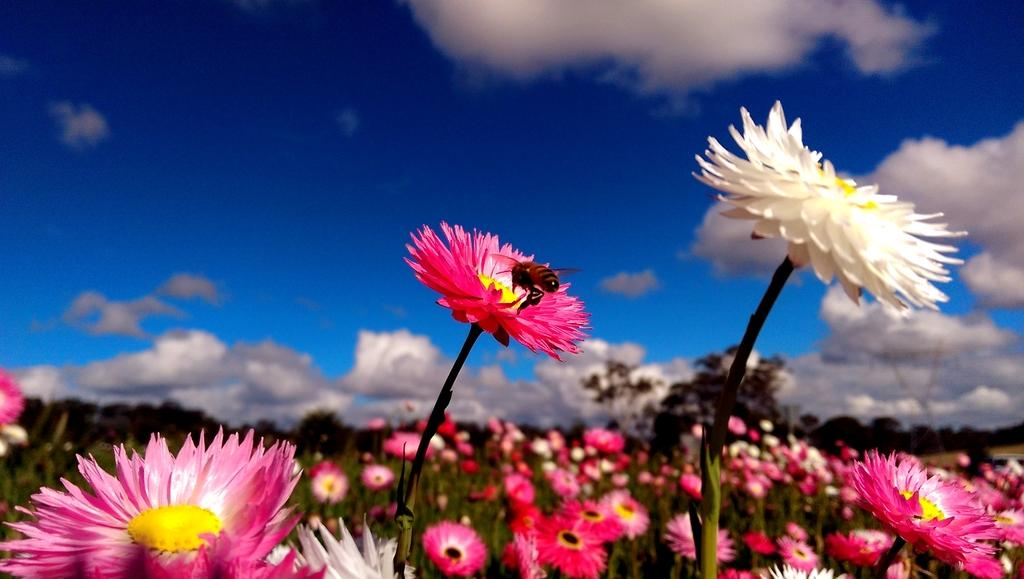What type of living organisms can be seen in the image? There are flowers and an insect in the image. What colors are the flowers in the image? The flowers are in white and pink colors. What color is the insect in the image? The insect is in brown color. What can be seen in the background of the image? The sky is in white and blue colors in the background of the image. What is the chance of winning a lottery in the image? There is no reference to a lottery or any chances of winning in the image. What type of plants are growing in the image? The image only features flowers, not plants in the traditional sense. 